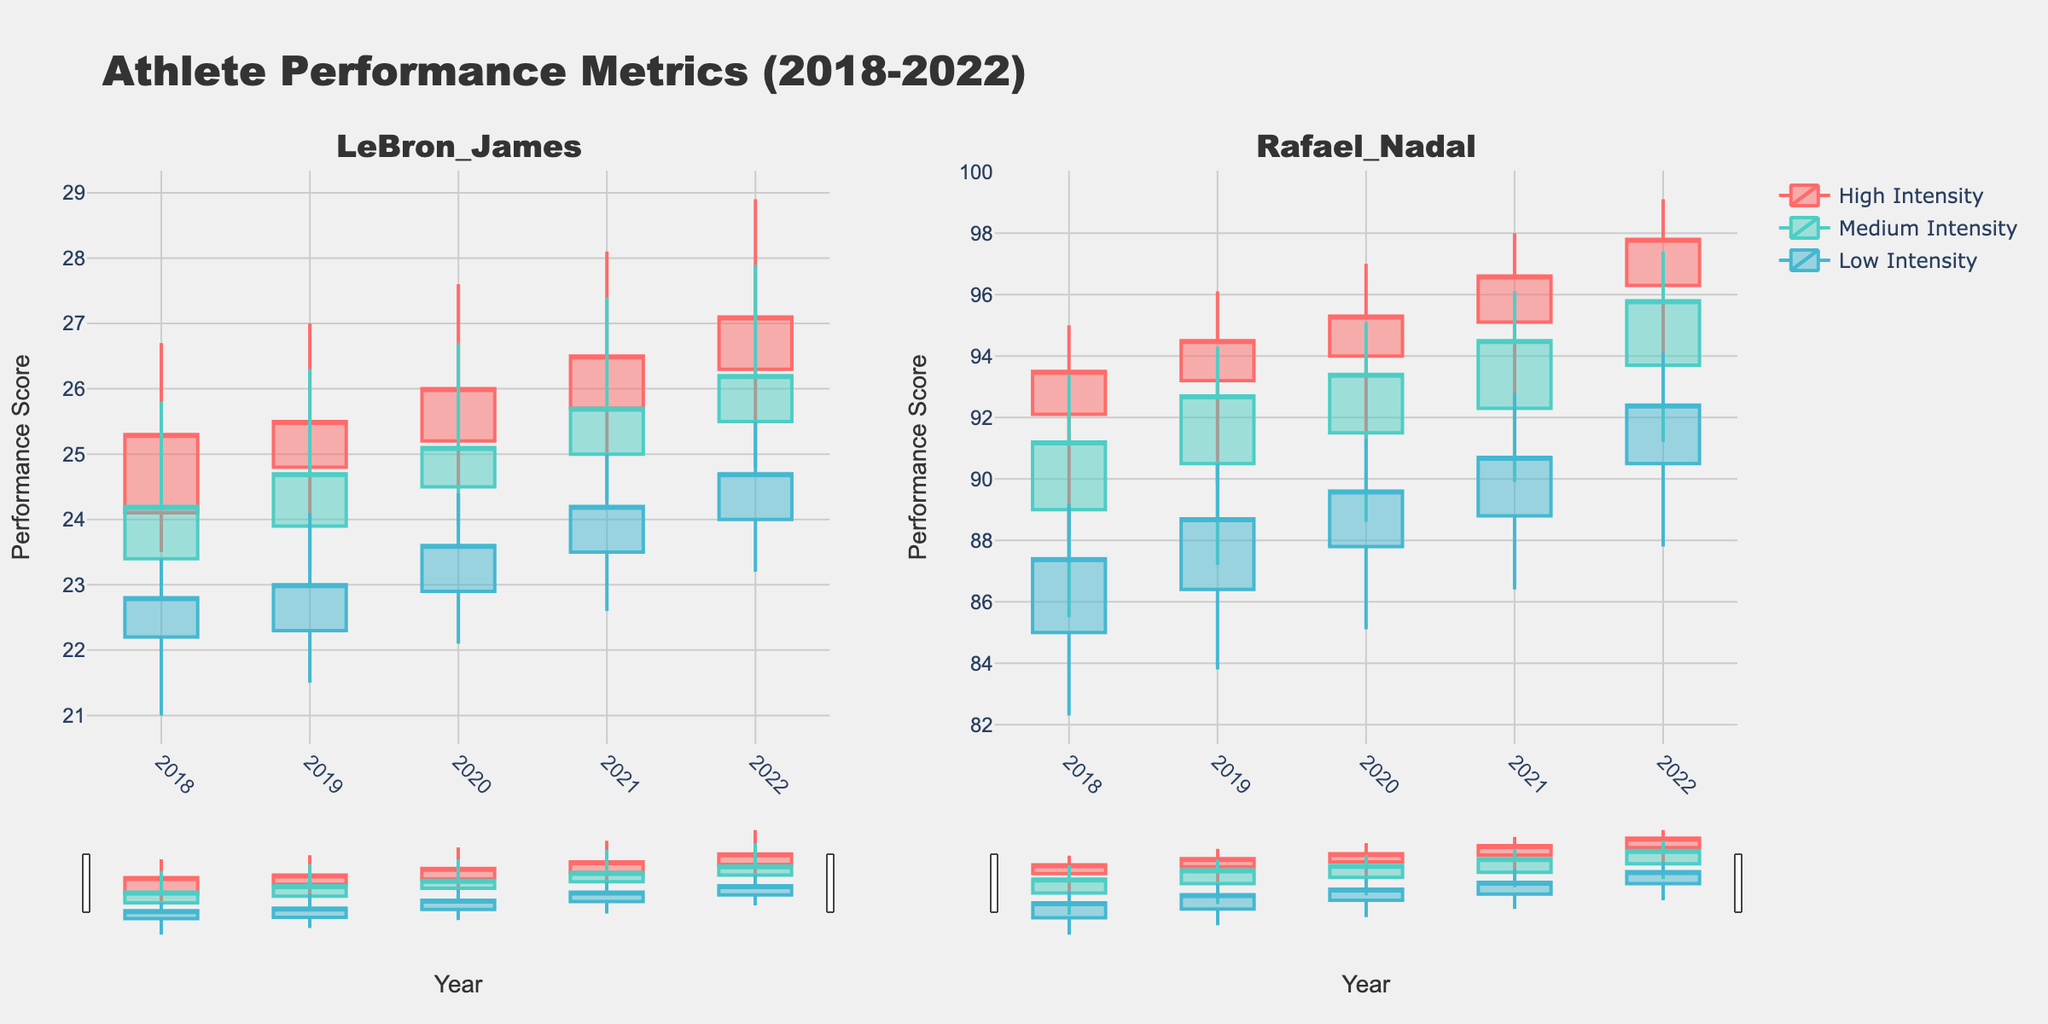what is the title of the plot? The title of the plot is written at the center top of the figure. It reads "Athlete Performance Metrics (2018-2022)."
Answer: Athlete Performance Metrics (2018-2022) what are the labels of the two subplots? The subplots are titled with the names of the two athletes, which are written above each subplot.
Answer: LeBron_James and Rafael_Nadal how do the performance scores of LeBron James compare between high and low training intensity in 2022? Compare the highest and lowest vertical bars in the 2022 data points under both High and Low training intensity for LeBron James. High training intensity shows higher scores than Low training intensity.
Answer: Higher in High intensity which athlete had a higher performance score in the High training intensity category in 2019? Compare the highest points in the High training intensity category for both LeBron James and Rafael Nadal in 2019. Rafael Nadal has a higher score.
Answer: Rafael Nadal what was the trend in Rafael Nadal's performance scores from 2018 to 2022 under medium training intensity? Look at the trend of the candlesticks for Rafael Nadal under Medium training intensity from 2018 to 2022. The scores show a consistent increase over the years.
Answer: Increasing trend what is the color used to represent Medium training intensity? The color used for Medium training intensity is visible in the legend and candlesticks with medium intensity data. It appears to be a light blue color.
Answer: Light blue what is the average Open_Performance score for LeBron James in the period of 2019-2021 under medium training intensity? Find the Open_Performance scores for LeBron James in Medium training intensity for years 2019, 2020, and 2021, then calculate the average: (23.9 + 24.5 + 25.0) / 3.
Answer: 24.47 which training intensity shows the most significant difference in High and Low performance scores for Rafael Nadal in 2020? Compare the differences between the High and Low performance scores for High, Medium, and Low training intensities for Rafael Nadal in 2020. The High training intensity shows the most significant difference.
Answer: High intensity which year did LeBron James achieve the highest High_Performance score under High training intensity? Look at the High_Performance scores for LeBron James under High training intensity across all the years. The highest value is in 2022.
Answer: 2022 